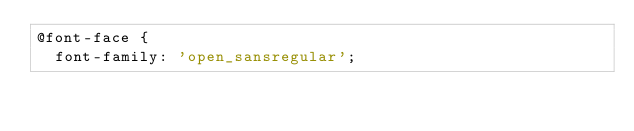<code> <loc_0><loc_0><loc_500><loc_500><_CSS_>@font-face {
  font-family: 'open_sansregular';</code> 